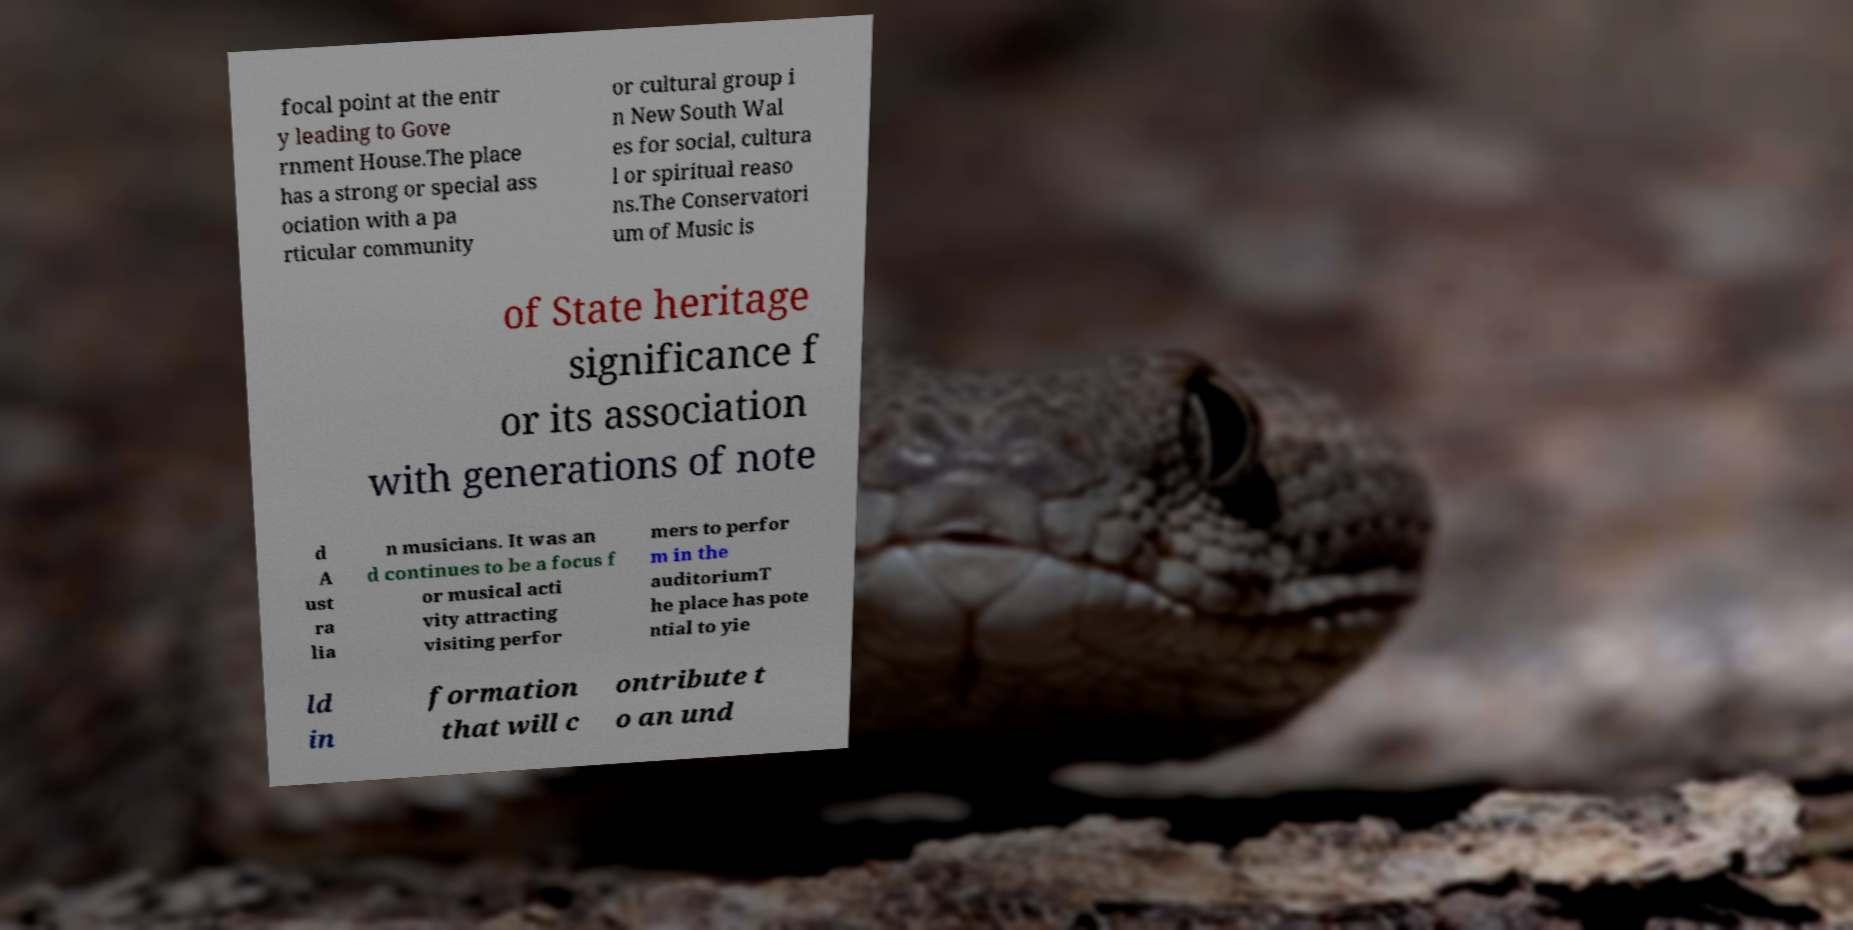There's text embedded in this image that I need extracted. Can you transcribe it verbatim? focal point at the entr y leading to Gove rnment House.The place has a strong or special ass ociation with a pa rticular community or cultural group i n New South Wal es for social, cultura l or spiritual reaso ns.The Conservatori um of Music is of State heritage significance f or its association with generations of note d A ust ra lia n musicians. It was an d continues to be a focus f or musical acti vity attracting visiting perfor mers to perfor m in the auditoriumT he place has pote ntial to yie ld in formation that will c ontribute t o an und 